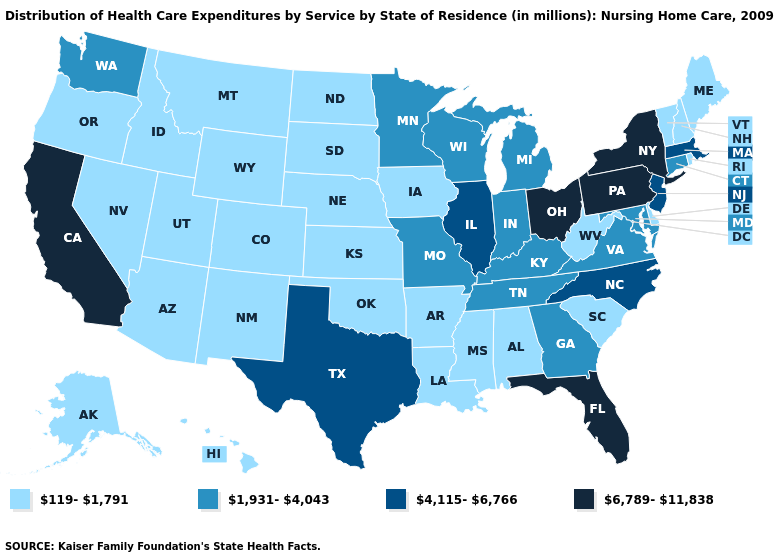Does Kentucky have the lowest value in the South?
Answer briefly. No. What is the highest value in the USA?
Give a very brief answer. 6,789-11,838. Does Florida have the highest value in the South?
Keep it brief. Yes. What is the value of Virginia?
Short answer required. 1,931-4,043. What is the lowest value in the Northeast?
Give a very brief answer. 119-1,791. What is the highest value in states that border South Carolina?
Keep it brief. 4,115-6,766. Does Ohio have the highest value in the MidWest?
Short answer required. Yes. Does California have the highest value in the West?
Write a very short answer. Yes. Is the legend a continuous bar?
Concise answer only. No. Name the states that have a value in the range 6,789-11,838?
Give a very brief answer. California, Florida, New York, Ohio, Pennsylvania. Name the states that have a value in the range 4,115-6,766?
Quick response, please. Illinois, Massachusetts, New Jersey, North Carolina, Texas. Name the states that have a value in the range 4,115-6,766?
Write a very short answer. Illinois, Massachusetts, New Jersey, North Carolina, Texas. How many symbols are there in the legend?
Give a very brief answer. 4. Does Utah have a lower value than Maryland?
Give a very brief answer. Yes. Name the states that have a value in the range 4,115-6,766?
Write a very short answer. Illinois, Massachusetts, New Jersey, North Carolina, Texas. 